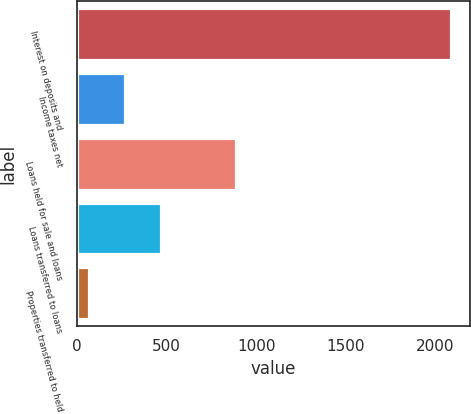<chart> <loc_0><loc_0><loc_500><loc_500><bar_chart><fcel>Interest on deposits and<fcel>Income taxes net<fcel>Loans held for sale and loans<fcel>Loans transferred to loans<fcel>Properties transferred to held<nl><fcel>2086<fcel>269.8<fcel>890<fcel>471.6<fcel>68<nl></chart> 